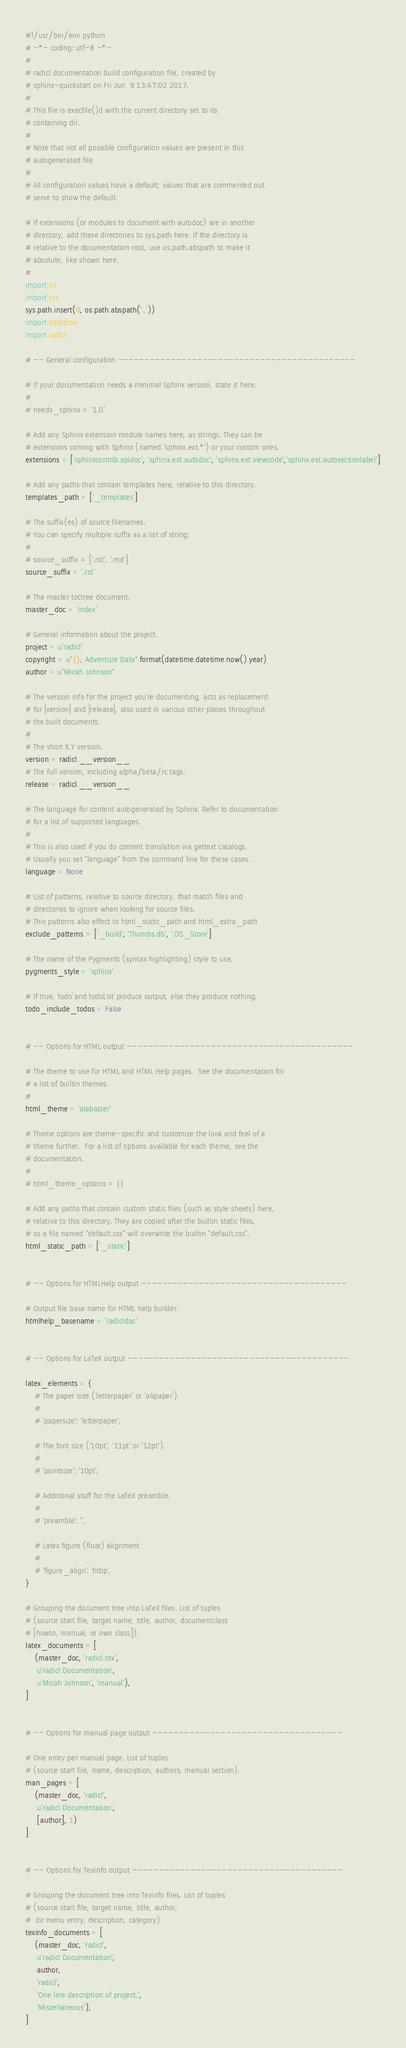<code> <loc_0><loc_0><loc_500><loc_500><_Python_>#!/usr/bin/env python
# -*- coding: utf-8 -*-
#
# radicl documentation build configuration file, created by
# sphinx-quickstart on Fri Jun  9 13:47:02 2017.
#
# This file is execfile()d with the current directory set to its
# containing dir.
#
# Note that not all possible configuration values are present in this
# autogenerated file.
#
# All configuration values have a default; values that are commented out
# serve to show the default.

# If extensions (or modules to document with autodoc) are in another
# directory, add these directories to sys.path here. If the directory is
# relative to the documentation root, use os.path.abspath to make it
# absolute, like shown here.
#
import os
import sys
sys.path.insert(0, os.path.abspath('..'))
import datetime
import radicl

# -- General configuration ---------------------------------------------

# If your documentation needs a minimal Sphinx version, state it here.
#
# needs_sphinx = '1.0'

# Add any Sphinx extension module names here, as strings. They can be
# extensions coming with Sphinx (named 'sphinx.ext.*') or your custom ones.
extensions = ['sphinxcontrib.apidoc', 'sphinx.ext.autodoc', 'sphinx.ext.viewcode','sphinx.ext.autosectionlabel']

# Add any paths that contain templates here, relative to this directory.
templates_path = ['_templates']

# The suffix(es) of source filenames.
# You can specify multiple suffix as a list of string:
#
# source_suffix = ['.rst', '.md']
source_suffix = '.rst'

# The master toctree document.
master_doc = 'index'

# General information about the project.
project = u'radicl'
copyright = u"{}, Adventure Data".format(datetime.datetime.now().year)
author = u"Micah Johnson"

# The version info for the project you're documenting, acts as replacement
# for |version| and |release|, also used in various other places throughout
# the built documents.
#
# The short X.Y version.
version = radicl.__version__
# The full version, including alpha/beta/rc tags.
release = radicl.__version__

# The language for content autogenerated by Sphinx. Refer to documentation
# for a list of supported languages.
#
# This is also used if you do content translation via gettext catalogs.
# Usually you set "language" from the command line for these cases.
language = None

# List of patterns, relative to source directory, that match files and
# directories to ignore when looking for source files.
# This patterns also effect to html_static_path and html_extra_path
exclude_patterns = ['_build', 'Thumbs.db', '.DS_Store']

# The name of the Pygments (syntax highlighting) style to use.
pygments_style = 'sphinx'

# If true, `todo` and `todoList` produce output, else they produce nothing.
todo_include_todos = False


# -- Options for HTML output -------------------------------------------

# The theme to use for HTML and HTML Help pages.  See the documentation for
# a list of builtin themes.
#
html_theme = 'alabaster'

# Theme options are theme-specific and customize the look and feel of a
# theme further.  For a list of options available for each theme, see the
# documentation.
#
# html_theme_options = {}

# Add any paths that contain custom static files (such as style sheets) here,
# relative to this directory. They are copied after the builtin static files,
# so a file named "default.css" will overwrite the builtin "default.css".
html_static_path = ['_static']


# -- Options for HTMLHelp output ---------------------------------------

# Output file base name for HTML help builder.
htmlhelp_basename = 'radicldoc'


# -- Options for LaTeX output ------------------------------------------

latex_elements = {
    # The paper size ('letterpaper' or 'a4paper').
    #
    # 'papersize': 'letterpaper',

    # The font size ('10pt', '11pt' or '12pt').
    #
    # 'pointsize': '10pt',

    # Additional stuff for the LaTeX preamble.
    #
    # 'preamble': '',

    # Latex figure (float) alignment
    #
    # 'figure_align': 'htbp',
}

# Grouping the document tree into LaTeX files. List of tuples
# (source start file, target name, title, author, documentclass
# [howto, manual, or own class]).
latex_documents = [
    (master_doc, 'radicl.tex',
     u'radicl Documentation',
     u'Micah Johnson', 'manual'),
]


# -- Options for manual page output ------------------------------------

# One entry per manual page. List of tuples
# (source start file, name, description, authors, manual section).
man_pages = [
    (master_doc, 'radicl',
     u'radicl Documentation',
     [author], 1)
]


# -- Options for Texinfo output ----------------------------------------

# Grouping the document tree into Texinfo files. List of tuples
# (source start file, target name, title, author,
#  dir menu entry, description, category)
texinfo_documents = [
    (master_doc, 'radicl',
     u'radicl Documentation',
     author,
     'radicl',
     'One line description of project.',
     'Miscellaneous'),
]
</code> 